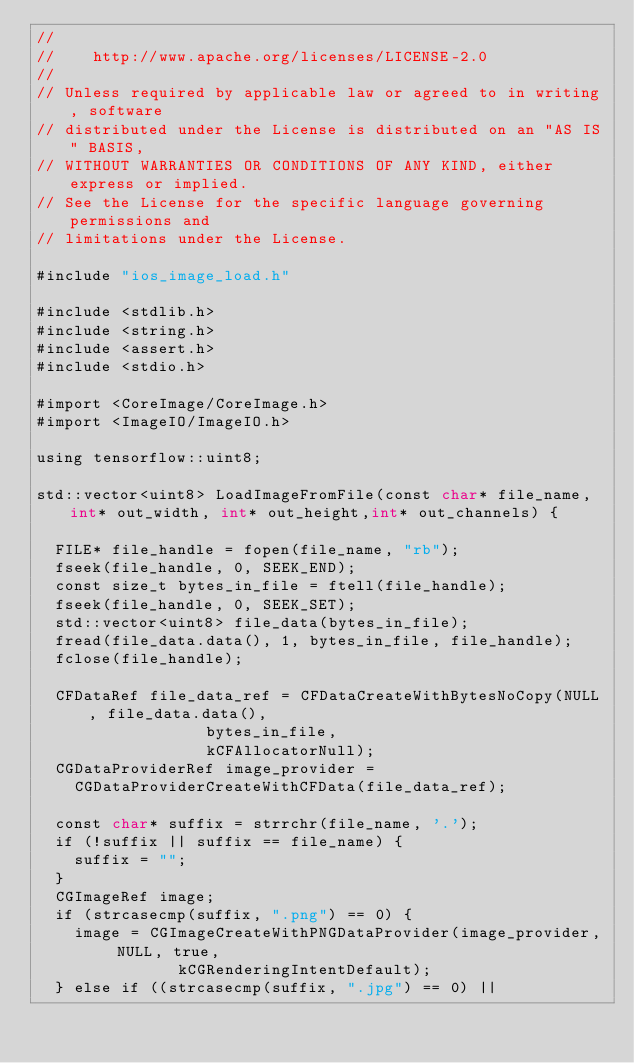<code> <loc_0><loc_0><loc_500><loc_500><_ObjectiveC_>//
//    http://www.apache.org/licenses/LICENSE-2.0
//
// Unless required by applicable law or agreed to in writing, software
// distributed under the License is distributed on an "AS IS" BASIS,
// WITHOUT WARRANTIES OR CONDITIONS OF ANY KIND, either express or implied.
// See the License for the specific language governing permissions and
// limitations under the License.

#include "ios_image_load.h"

#include <stdlib.h>
#include <string.h>
#include <assert.h>
#include <stdio.h>

#import <CoreImage/CoreImage.h>
#import <ImageIO/ImageIO.h>

using tensorflow::uint8;

std::vector<uint8> LoadImageFromFile(const char* file_name, int* out_width, int* out_height,int* out_channels) {
    
  FILE* file_handle = fopen(file_name, "rb");
  fseek(file_handle, 0, SEEK_END);
  const size_t bytes_in_file = ftell(file_handle);
  fseek(file_handle, 0, SEEK_SET);
  std::vector<uint8> file_data(bytes_in_file);
  fread(file_data.data(), 1, bytes_in_file, file_handle);
  fclose(file_handle);
    
  CFDataRef file_data_ref = CFDataCreateWithBytesNoCopy(NULL, file_data.data(),
						      bytes_in_file,
						      kCFAllocatorNull);
  CGDataProviderRef image_provider =
    CGDataProviderCreateWithCFData(file_data_ref);

  const char* suffix = strrchr(file_name, '.');
  if (!suffix || suffix == file_name) {
    suffix = "";
  }
  CGImageRef image;
  if (strcasecmp(suffix, ".png") == 0) {
    image = CGImageCreateWithPNGDataProvider(image_provider, NULL, true,
					     kCGRenderingIntentDefault);
  } else if ((strcasecmp(suffix, ".jpg") == 0) ||</code> 